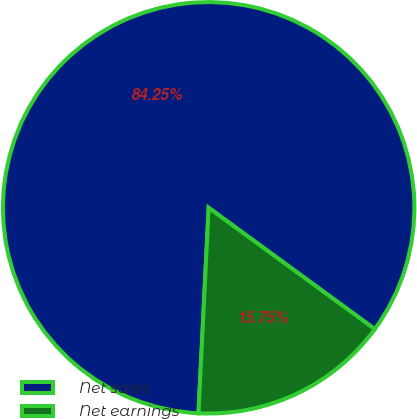Convert chart. <chart><loc_0><loc_0><loc_500><loc_500><pie_chart><fcel>Net sales<fcel>Net earnings<nl><fcel>84.25%<fcel>15.75%<nl></chart> 